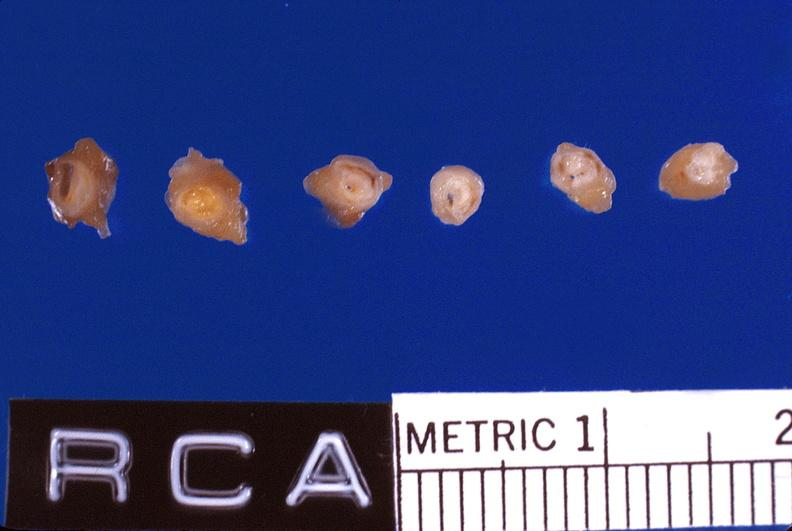what is present?
Answer the question using a single word or phrase. Vasculature 